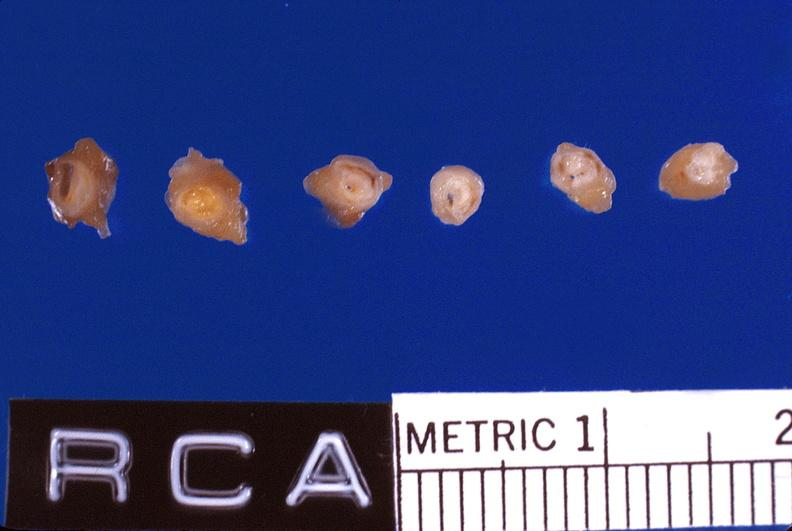what is present?
Answer the question using a single word or phrase. Vasculature 